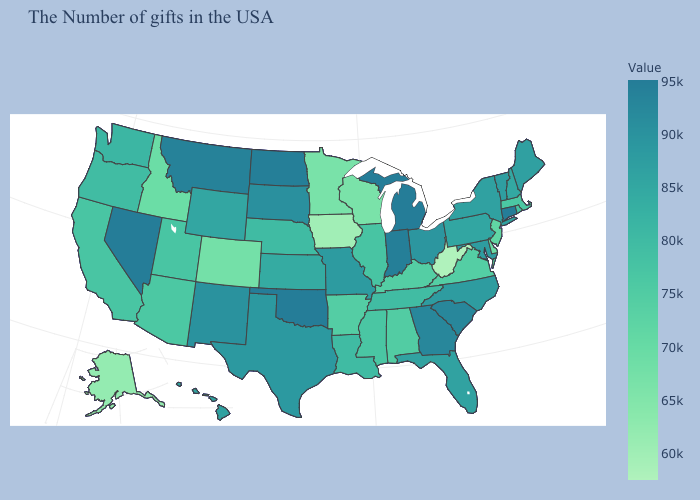Does Mississippi have a lower value than New Hampshire?
Answer briefly. Yes. Among the states that border Florida , which have the highest value?
Keep it brief. Georgia. Does Pennsylvania have a lower value than Delaware?
Short answer required. No. 